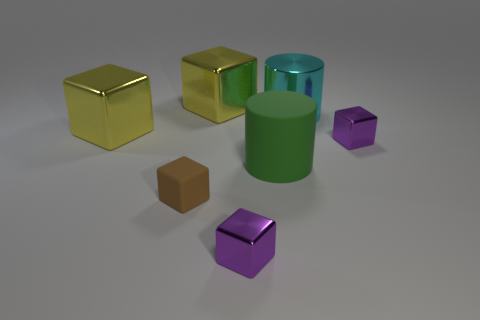Do the cyan cylinder and the matte cylinder have the same size?
Your answer should be compact. Yes. What is the small cube that is on the right side of the tiny metallic cube that is to the left of the tiny purple thing that is behind the green matte cylinder made of?
Your answer should be compact. Metal. How many other objects are there of the same color as the matte block?
Your answer should be compact. 0. What is the shape of the cyan shiny object?
Your response must be concise. Cylinder. There is a green thing that is the same size as the cyan metallic thing; what is its material?
Your answer should be very brief. Rubber. There is a big shiny thing that is behind the big cyan thing; does it have the same color as the metallic cube that is to the left of the small matte cube?
Make the answer very short. Yes. Are there any green rubber objects of the same shape as the cyan object?
Ensure brevity in your answer.  Yes. What shape is the cyan object that is the same size as the green cylinder?
Your answer should be compact. Cylinder. What number of other matte cylinders are the same color as the matte cylinder?
Keep it short and to the point. 0. There is a metal cube behind the large cyan metal thing; what size is it?
Give a very brief answer. Large. 